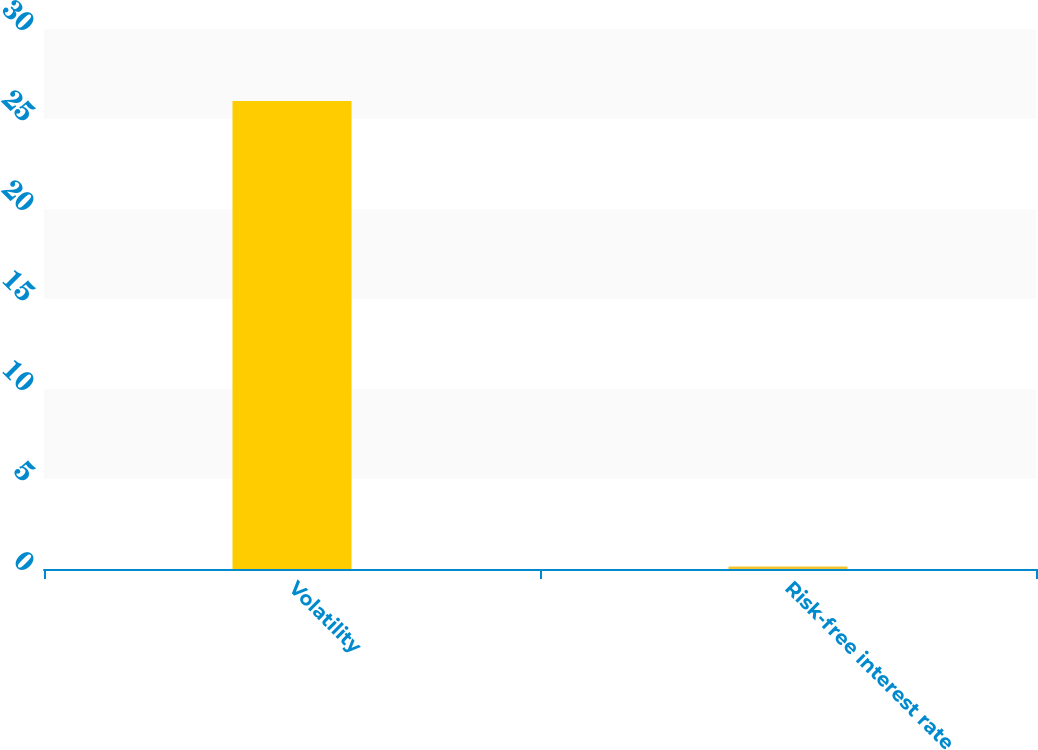Convert chart to OTSL. <chart><loc_0><loc_0><loc_500><loc_500><bar_chart><fcel>Volatility<fcel>Risk-free interest rate<nl><fcel>26<fcel>0.14<nl></chart> 